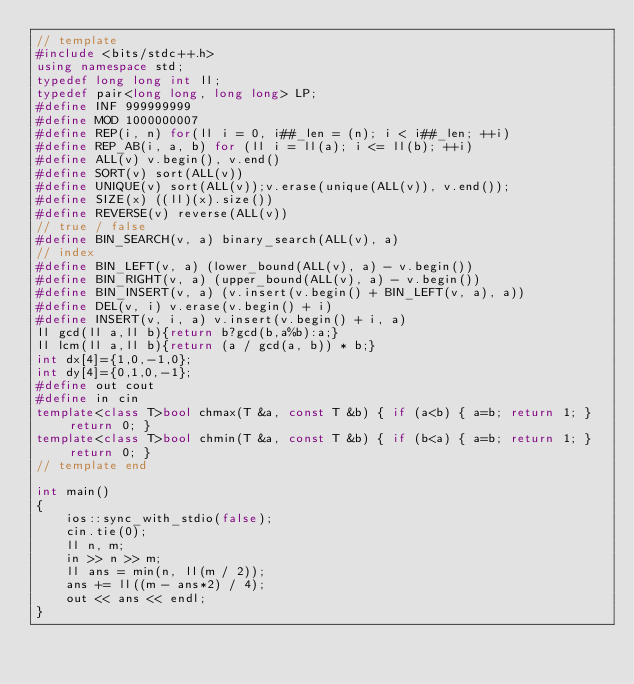<code> <loc_0><loc_0><loc_500><loc_500><_C++_>// template
#include <bits/stdc++.h>
using namespace std;
typedef long long int ll;
typedef pair<long long, long long> LP;
#define INF 999999999
#define MOD 1000000007
#define REP(i, n) for(ll i = 0, i##_len = (n); i < i##_len; ++i)
#define REP_AB(i, a, b) for (ll i = ll(a); i <= ll(b); ++i)
#define ALL(v) v.begin(), v.end()
#define SORT(v) sort(ALL(v))
#define UNIQUE(v) sort(ALL(v));v.erase(unique(ALL(v)), v.end());
#define SIZE(x) ((ll)(x).size())
#define REVERSE(v) reverse(ALL(v))
// true / false
#define BIN_SEARCH(v, a) binary_search(ALL(v), a)
// index
#define BIN_LEFT(v, a) (lower_bound(ALL(v), a) - v.begin())
#define BIN_RIGHT(v, a) (upper_bound(ALL(v), a) - v.begin())
#define BIN_INSERT(v, a) (v.insert(v.begin() + BIN_LEFT(v, a), a))
#define DEL(v, i) v.erase(v.begin() + i)
#define INSERT(v, i, a) v.insert(v.begin() + i, a)
ll gcd(ll a,ll b){return b?gcd(b,a%b):a;}
ll lcm(ll a,ll b){return (a / gcd(a, b)) * b;}
int dx[4]={1,0,-1,0};
int dy[4]={0,1,0,-1};
#define out cout
#define in cin
template<class T>bool chmax(T &a, const T &b) { if (a<b) { a=b; return 1; } return 0; }
template<class T>bool chmin(T &a, const T &b) { if (b<a) { a=b; return 1; } return 0; }
// template end

int main()
{
    ios::sync_with_stdio(false);
    cin.tie(0);
    ll n, m;
    in >> n >> m;
    ll ans = min(n, ll(m / 2));
    ans += ll((m - ans*2) / 4);
    out << ans << endl;
}
</code> 